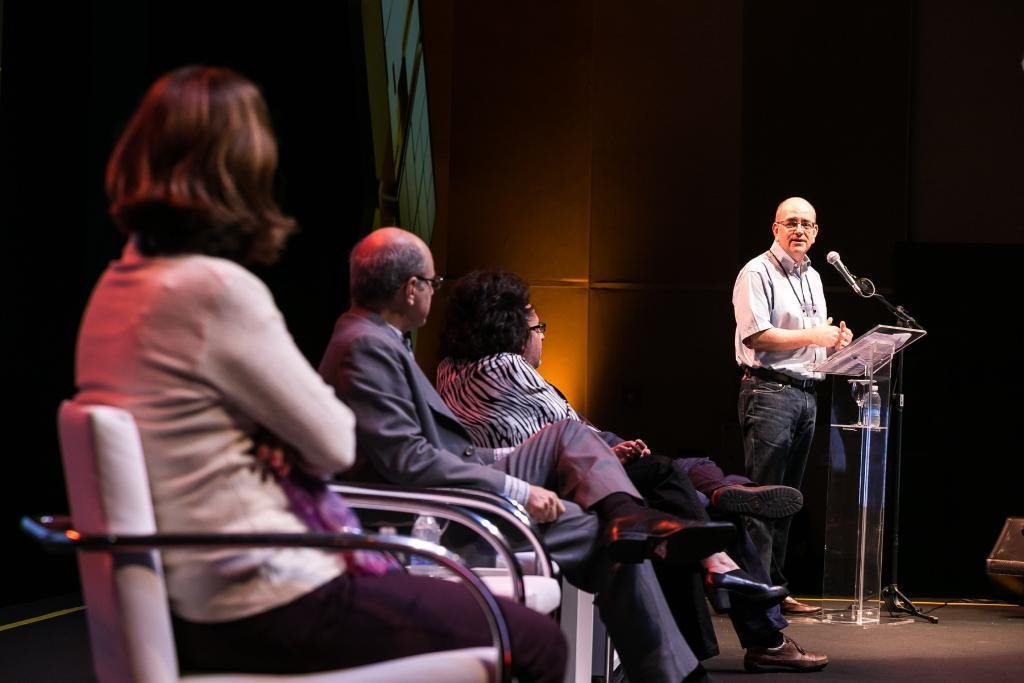What are the people in the image doing? There are persons sitting on chairs in the image. What can be seen in the background of the image? There is a wall and a person standing near a podium in the background of the image. What is visible beneath the people and the podium? The floor is visible in the image. What type of haircut is the government giving in the image? There is no reference to a haircut or the government in the image; it features persons sitting on chairs and a person standing near a podium. How does the person standing near the podium fall in the image? The person standing near the podium does not fall in the image; they are standing upright. 